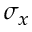Convert formula to latex. <formula><loc_0><loc_0><loc_500><loc_500>\sigma _ { x }</formula> 